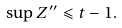Convert formula to latex. <formula><loc_0><loc_0><loc_500><loc_500>\sup Z ^ { \prime \prime } \leqslant t - 1 .</formula> 